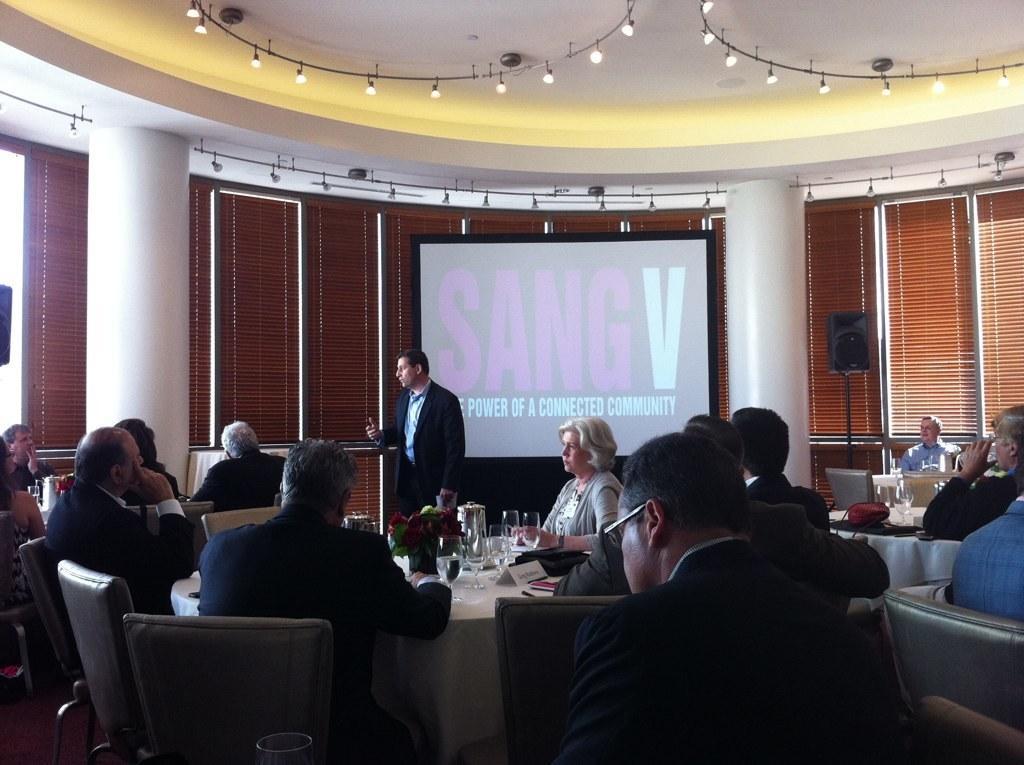Can you describe this image briefly? There is a group of persons sitting on the chairs as we can see at the bottom of this image. There is one person wearing black color blazer in the middle of this image, and there is a wall in the background. There are some glasses and some other objects are kept on a table which is covered with white color cloth. There is a screen in the middle of this image, and there are some lights present at the top of this image. 